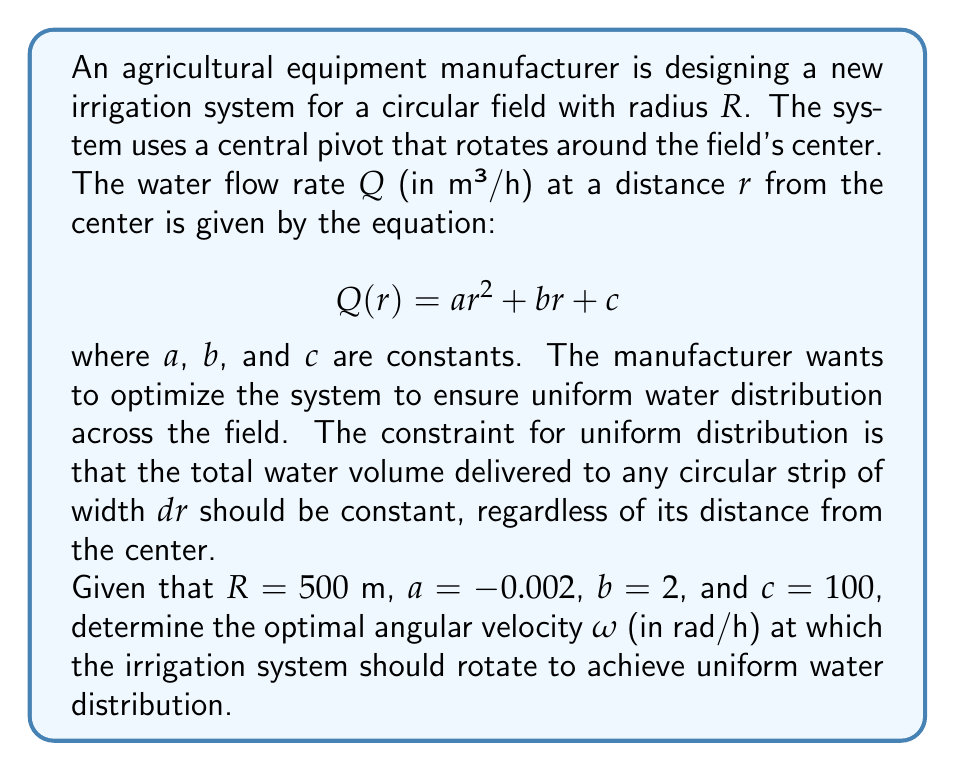Give your solution to this math problem. Let's approach this step-by-step:

1) For uniform water distribution, the volume of water delivered to any circular strip of width $dr$ should be constant. This volume is proportional to $Q(r) \cdot 2\pi r \cdot dr$.

2) For this to be constant, we need:

   $$Q(r) \cdot r = K$$

   where $K$ is a constant.

3) Substituting the given equation for $Q(r)$:

   $$(ar^2 + br + c) \cdot r = K$$

4) Expanding this:

   $$ar^3 + br^2 + cr = K$$

5) Substituting the given values:

   $$-0.002r^3 + 2r^2 + 100r = K$$

6) This equation should hold for all values of $r$ from 0 to $R$. We can determine $K$ by using $r = R = 500$:

   $$K = -0.002(500^3) + 2(500^2) + 100(500) = 575,000$$

7) Now, the total water volume delivered in one rotation is:

   $$V = \int_0^R Q(r) \cdot 2\pi r \cdot dr$$

8) Substituting the expression for $Q(r)$:

   $$V = 2\pi \int_0^R (ar^2 + br + c) \cdot r \cdot dr$$

9) Evaluating this integral:

   $$V = 2\pi [\frac{a}{4}r^4 + \frac{b}{3}r^3 + \frac{c}{2}r^2]_0^R$$

10) Substituting the values:

    $$V = 2\pi [-0.002 \cdot \frac{500^4}{4} + 2 \cdot \frac{500^3}{3} + 100 \cdot \frac{500^2}{2}]$$
    $$V \approx 130,899,470 \text{ m}^3$$

11) The time for one rotation should be such that this volume equals the total volume delivered to the field, which is $K \cdot \pi R^2$:

    $$130,899,470 = 575,000 \cdot \pi \cdot 500^2 \cdot T$$

    where $T$ is the time for one rotation in hours.

12) Solving for $T$:

    $$T \approx 0.2907 \text{ hours}$$

13) The angular velocity $\omega$ is given by:

    $$\omega = \frac{2\pi}{T} \approx 21.61 \text{ rad/h}$$
Answer: $\omega \approx 21.61 \text{ rad/h}$ 